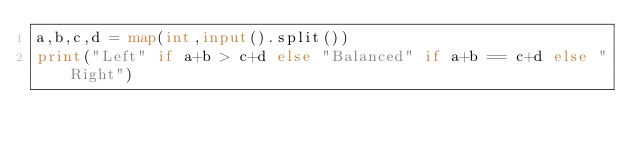Convert code to text. <code><loc_0><loc_0><loc_500><loc_500><_Python_>a,b,c,d = map(int,input().split())
print("Left" if a+b > c+d else "Balanced" if a+b == c+d else "Right")</code> 